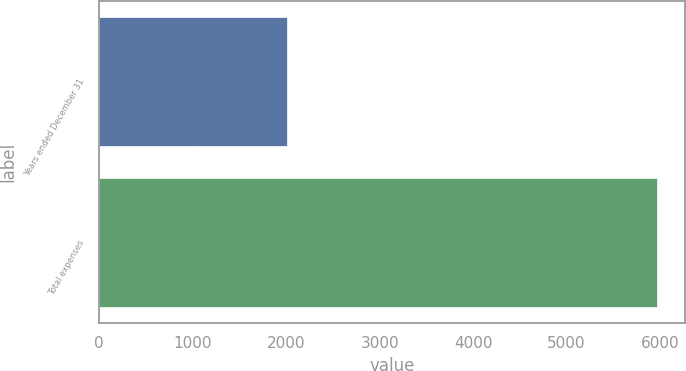Convert chart. <chart><loc_0><loc_0><loc_500><loc_500><bar_chart><fcel>Years ended December 31<fcel>Total expenses<nl><fcel>2009<fcel>5966<nl></chart> 